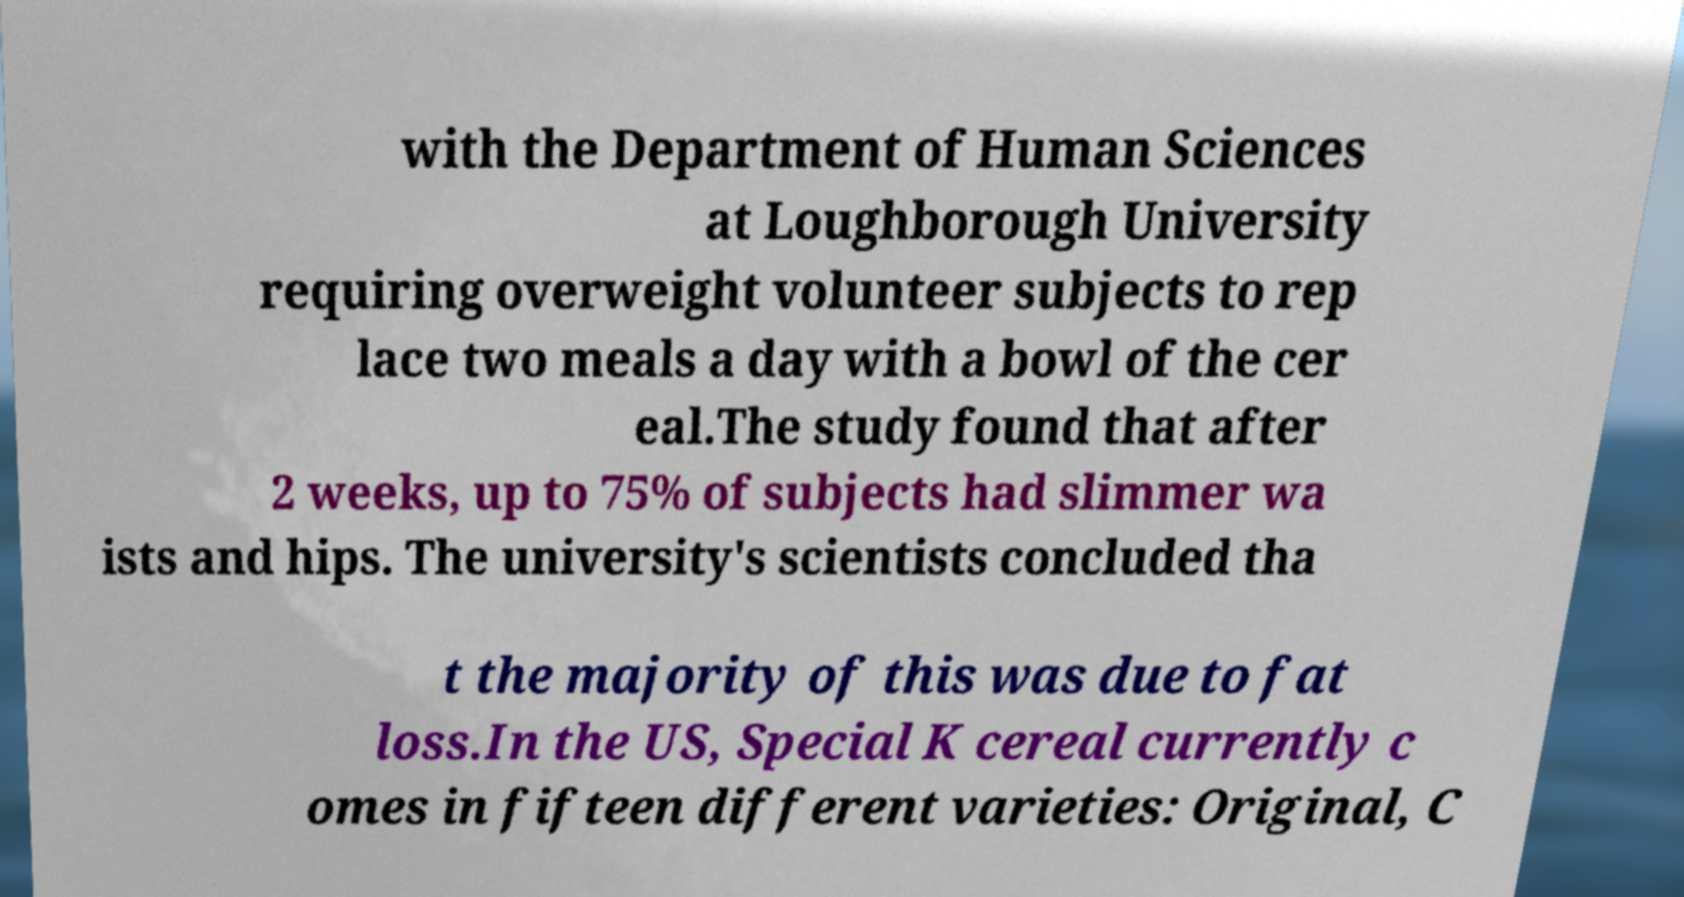Can you read and provide the text displayed in the image?This photo seems to have some interesting text. Can you extract and type it out for me? with the Department of Human Sciences at Loughborough University requiring overweight volunteer subjects to rep lace two meals a day with a bowl of the cer eal.The study found that after 2 weeks, up to 75% of subjects had slimmer wa ists and hips. The university's scientists concluded tha t the majority of this was due to fat loss.In the US, Special K cereal currently c omes in fifteen different varieties: Original, C 